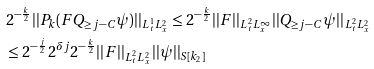<formula> <loc_0><loc_0><loc_500><loc_500>& 2 ^ { - \frac { k } { 2 } } | | P _ { k } ( F Q _ { \geq j - C } \psi ) | | _ { L _ { t } ^ { 1 } L _ { x } ^ { 2 } } \leq 2 ^ { - \frac { k } { 2 } } | | F | | _ { L _ { t } ^ { 2 } L _ { x } ^ { \infty } } | | Q _ { \geq j - C } \psi | | _ { L _ { t } ^ { 2 } L _ { x } ^ { 2 } } \\ & \leq 2 ^ { - \frac { j } { 2 } } 2 ^ { \delta j } 2 ^ { - \frac { k } { 2 } } | | F | | _ { L _ { t } ^ { 2 } L _ { x } ^ { 2 } } | | \psi | | _ { S [ k _ { 2 } ] } \\</formula> 